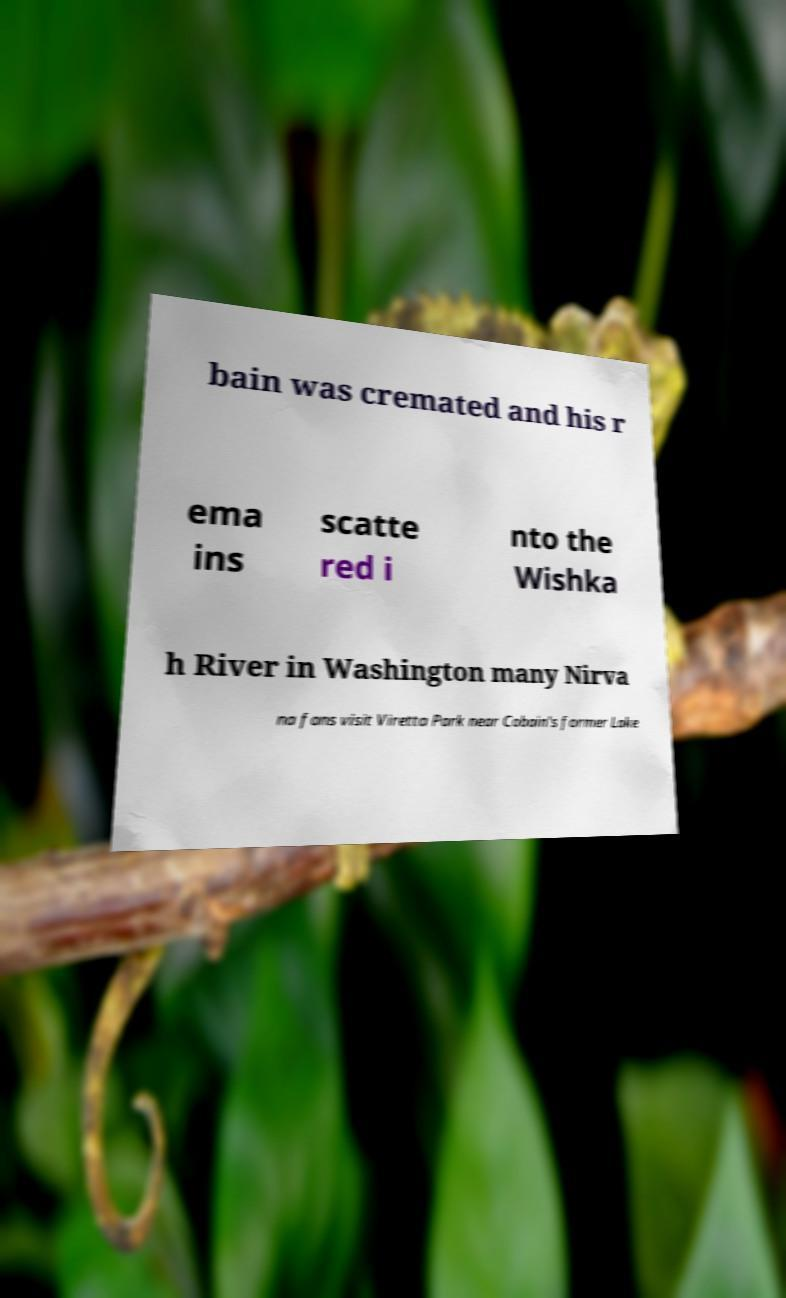I need the written content from this picture converted into text. Can you do that? bain was cremated and his r ema ins scatte red i nto the Wishka h River in Washington many Nirva na fans visit Viretta Park near Cobain's former Lake 